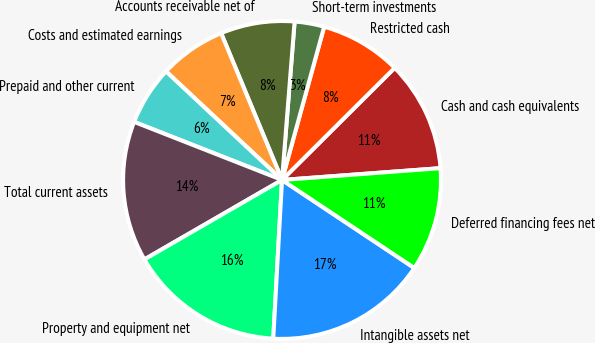Convert chart. <chart><loc_0><loc_0><loc_500><loc_500><pie_chart><fcel>Cash and cash equivalents<fcel>Restricted cash<fcel>Short-term investments<fcel>Accounts receivable net of<fcel>Costs and estimated earnings<fcel>Prepaid and other current<fcel>Total current assets<fcel>Property and equipment net<fcel>Intangible assets net<fcel>Deferred financing fees net<nl><fcel>11.28%<fcel>8.27%<fcel>3.01%<fcel>7.52%<fcel>6.77%<fcel>6.02%<fcel>14.29%<fcel>15.79%<fcel>16.54%<fcel>10.53%<nl></chart> 